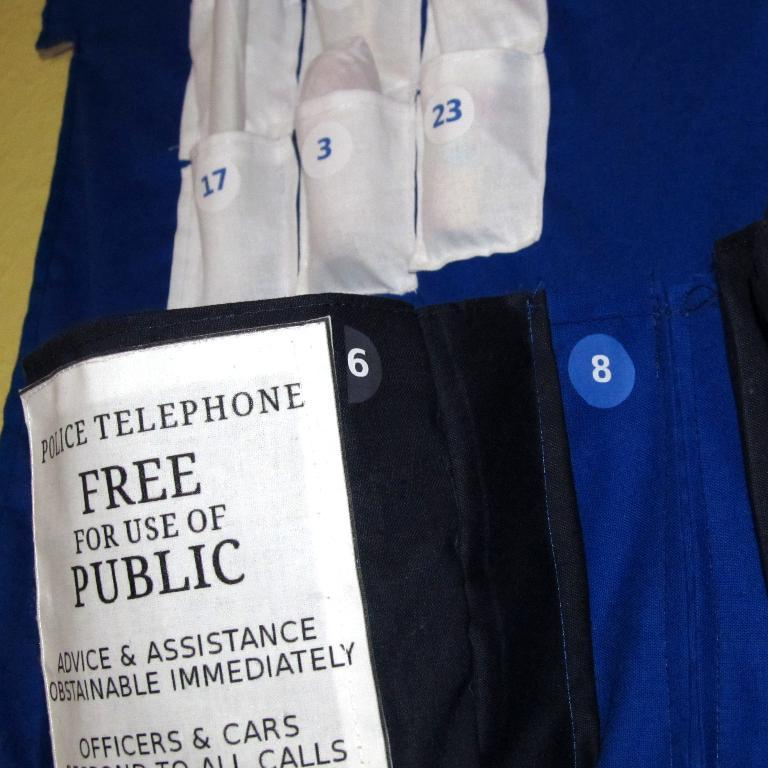Provide a one-sentence caption for the provided image. A sign offering a police phone for public use mentions it is free. 